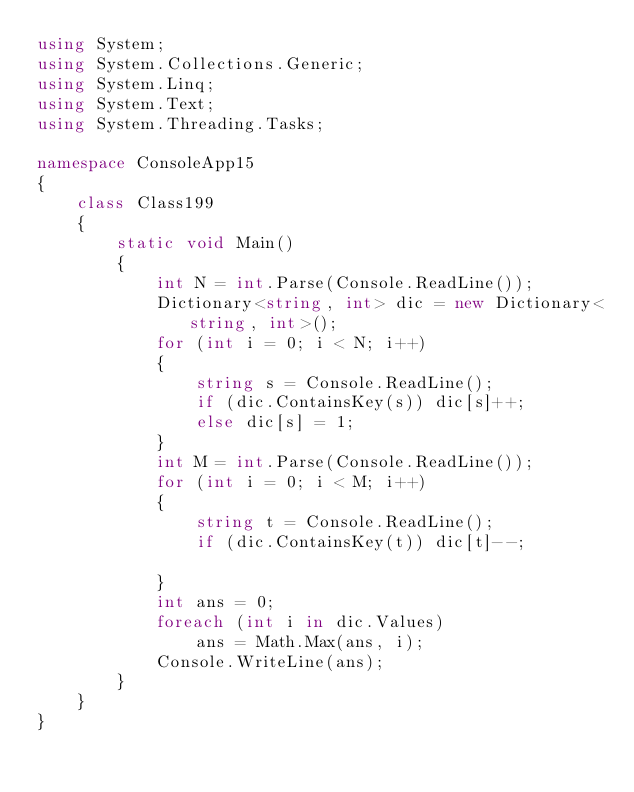Convert code to text. <code><loc_0><loc_0><loc_500><loc_500><_C#_>using System;
using System.Collections.Generic;
using System.Linq;
using System.Text;
using System.Threading.Tasks;

namespace ConsoleApp15
{
    class Class199
    {
        static void Main()
        {
            int N = int.Parse(Console.ReadLine());
            Dictionary<string, int> dic = new Dictionary<string, int>();
            for (int i = 0; i < N; i++)
            {
                string s = Console.ReadLine();
                if (dic.ContainsKey(s)) dic[s]++;
                else dic[s] = 1;
            }
            int M = int.Parse(Console.ReadLine());
            for (int i = 0; i < M; i++)
            {
                string t = Console.ReadLine();
                if (dic.ContainsKey(t)) dic[t]--;

            }
            int ans = 0;
            foreach (int i in dic.Values)
                ans = Math.Max(ans, i);
            Console.WriteLine(ans);
        }
    }
}
</code> 